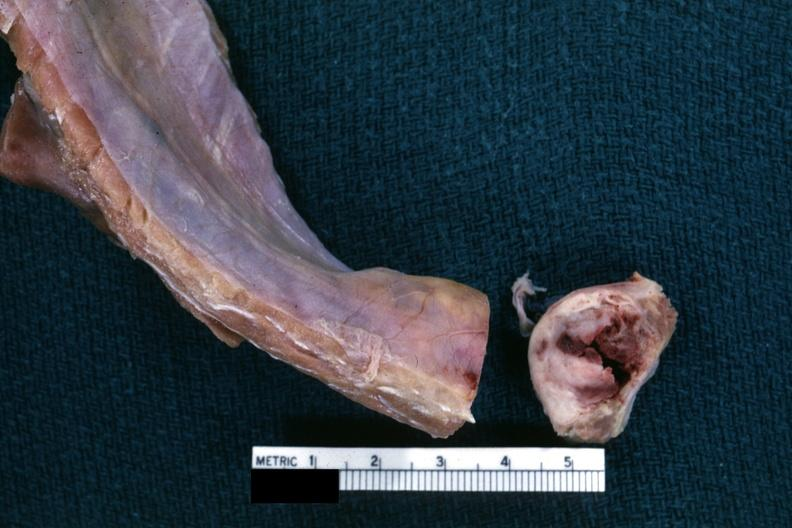s lesion cross sectioned to show white neoplasm with central hemorrhage?
Answer the question using a single word or phrase. Yes 